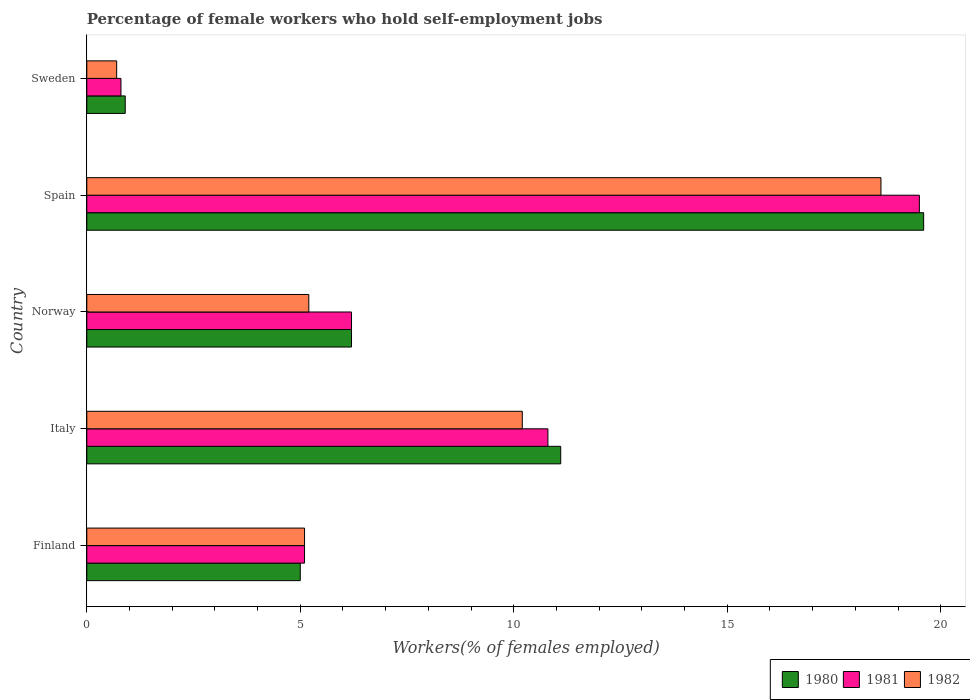How many groups of bars are there?
Offer a very short reply. 5. Are the number of bars per tick equal to the number of legend labels?
Make the answer very short. Yes. How many bars are there on the 3rd tick from the top?
Your answer should be very brief. 3. How many bars are there on the 5th tick from the bottom?
Give a very brief answer. 3. What is the percentage of self-employed female workers in 1981 in Sweden?
Give a very brief answer. 0.8. Across all countries, what is the maximum percentage of self-employed female workers in 1980?
Your response must be concise. 19.6. Across all countries, what is the minimum percentage of self-employed female workers in 1980?
Your response must be concise. 0.9. In which country was the percentage of self-employed female workers in 1981 maximum?
Make the answer very short. Spain. What is the total percentage of self-employed female workers in 1981 in the graph?
Ensure brevity in your answer.  42.4. What is the difference between the percentage of self-employed female workers in 1981 in Spain and that in Sweden?
Keep it short and to the point. 18.7. What is the difference between the percentage of self-employed female workers in 1980 in Spain and the percentage of self-employed female workers in 1982 in Finland?
Make the answer very short. 14.5. What is the average percentage of self-employed female workers in 1980 per country?
Ensure brevity in your answer.  8.56. What is the difference between the percentage of self-employed female workers in 1981 and percentage of self-employed female workers in 1980 in Norway?
Provide a short and direct response. 0. In how many countries, is the percentage of self-employed female workers in 1981 greater than 3 %?
Ensure brevity in your answer.  4. What is the ratio of the percentage of self-employed female workers in 1982 in Finland to that in Spain?
Ensure brevity in your answer.  0.27. Is the difference between the percentage of self-employed female workers in 1981 in Finland and Italy greater than the difference between the percentage of self-employed female workers in 1980 in Finland and Italy?
Offer a very short reply. Yes. What is the difference between the highest and the second highest percentage of self-employed female workers in 1982?
Ensure brevity in your answer.  8.4. What is the difference between the highest and the lowest percentage of self-employed female workers in 1980?
Your response must be concise. 18.7. In how many countries, is the percentage of self-employed female workers in 1980 greater than the average percentage of self-employed female workers in 1980 taken over all countries?
Make the answer very short. 2. What does the 3rd bar from the top in Spain represents?
Your response must be concise. 1980. How many bars are there?
Your answer should be very brief. 15. Are all the bars in the graph horizontal?
Offer a terse response. Yes. Does the graph contain grids?
Provide a succinct answer. No. How many legend labels are there?
Provide a short and direct response. 3. How are the legend labels stacked?
Keep it short and to the point. Horizontal. What is the title of the graph?
Offer a terse response. Percentage of female workers who hold self-employment jobs. Does "1982" appear as one of the legend labels in the graph?
Your response must be concise. Yes. What is the label or title of the X-axis?
Provide a short and direct response. Workers(% of females employed). What is the Workers(% of females employed) of 1981 in Finland?
Your answer should be compact. 5.1. What is the Workers(% of females employed) in 1982 in Finland?
Offer a very short reply. 5.1. What is the Workers(% of females employed) in 1980 in Italy?
Keep it short and to the point. 11.1. What is the Workers(% of females employed) in 1981 in Italy?
Ensure brevity in your answer.  10.8. What is the Workers(% of females employed) of 1982 in Italy?
Provide a succinct answer. 10.2. What is the Workers(% of females employed) of 1980 in Norway?
Your response must be concise. 6.2. What is the Workers(% of females employed) in 1981 in Norway?
Keep it short and to the point. 6.2. What is the Workers(% of females employed) of 1982 in Norway?
Keep it short and to the point. 5.2. What is the Workers(% of females employed) of 1980 in Spain?
Your response must be concise. 19.6. What is the Workers(% of females employed) of 1982 in Spain?
Your answer should be very brief. 18.6. What is the Workers(% of females employed) in 1980 in Sweden?
Make the answer very short. 0.9. What is the Workers(% of females employed) in 1981 in Sweden?
Your response must be concise. 0.8. What is the Workers(% of females employed) of 1982 in Sweden?
Provide a succinct answer. 0.7. Across all countries, what is the maximum Workers(% of females employed) in 1980?
Your answer should be very brief. 19.6. Across all countries, what is the maximum Workers(% of females employed) in 1982?
Your response must be concise. 18.6. Across all countries, what is the minimum Workers(% of females employed) in 1980?
Offer a terse response. 0.9. Across all countries, what is the minimum Workers(% of females employed) in 1981?
Your answer should be very brief. 0.8. Across all countries, what is the minimum Workers(% of females employed) in 1982?
Your response must be concise. 0.7. What is the total Workers(% of females employed) in 1980 in the graph?
Make the answer very short. 42.8. What is the total Workers(% of females employed) of 1981 in the graph?
Offer a very short reply. 42.4. What is the total Workers(% of females employed) of 1982 in the graph?
Your response must be concise. 39.8. What is the difference between the Workers(% of females employed) in 1980 in Finland and that in Italy?
Your answer should be compact. -6.1. What is the difference between the Workers(% of females employed) of 1981 in Finland and that in Italy?
Your answer should be very brief. -5.7. What is the difference between the Workers(% of females employed) of 1981 in Finland and that in Norway?
Your answer should be compact. -1.1. What is the difference between the Workers(% of females employed) of 1980 in Finland and that in Spain?
Keep it short and to the point. -14.6. What is the difference between the Workers(% of females employed) in 1981 in Finland and that in Spain?
Your response must be concise. -14.4. What is the difference between the Workers(% of females employed) in 1982 in Finland and that in Spain?
Your answer should be very brief. -13.5. What is the difference between the Workers(% of females employed) of 1981 in Italy and that in Norway?
Your answer should be compact. 4.6. What is the difference between the Workers(% of females employed) of 1982 in Italy and that in Norway?
Provide a succinct answer. 5. What is the difference between the Workers(% of females employed) in 1981 in Italy and that in Spain?
Keep it short and to the point. -8.7. What is the difference between the Workers(% of females employed) of 1982 in Italy and that in Spain?
Make the answer very short. -8.4. What is the difference between the Workers(% of females employed) of 1980 in Italy and that in Sweden?
Provide a succinct answer. 10.2. What is the difference between the Workers(% of females employed) of 1981 in Norway and that in Spain?
Make the answer very short. -13.3. What is the difference between the Workers(% of females employed) in 1980 in Norway and that in Sweden?
Give a very brief answer. 5.3. What is the difference between the Workers(% of females employed) of 1981 in Norway and that in Sweden?
Your answer should be compact. 5.4. What is the difference between the Workers(% of females employed) of 1980 in Spain and that in Sweden?
Provide a short and direct response. 18.7. What is the difference between the Workers(% of females employed) of 1980 in Finland and the Workers(% of females employed) of 1982 in Italy?
Ensure brevity in your answer.  -5.2. What is the difference between the Workers(% of females employed) of 1981 in Finland and the Workers(% of females employed) of 1982 in Italy?
Provide a short and direct response. -5.1. What is the difference between the Workers(% of females employed) in 1980 in Finland and the Workers(% of females employed) in 1981 in Spain?
Make the answer very short. -14.5. What is the difference between the Workers(% of females employed) in 1981 in Finland and the Workers(% of females employed) in 1982 in Spain?
Provide a short and direct response. -13.5. What is the difference between the Workers(% of females employed) in 1981 in Finland and the Workers(% of females employed) in 1982 in Sweden?
Your response must be concise. 4.4. What is the difference between the Workers(% of females employed) of 1980 in Italy and the Workers(% of females employed) of 1982 in Norway?
Offer a terse response. 5.9. What is the difference between the Workers(% of females employed) of 1980 in Italy and the Workers(% of females employed) of 1981 in Spain?
Offer a very short reply. -8.4. What is the difference between the Workers(% of females employed) in 1980 in Italy and the Workers(% of females employed) in 1982 in Spain?
Your response must be concise. -7.5. What is the difference between the Workers(% of females employed) of 1980 in Italy and the Workers(% of females employed) of 1982 in Sweden?
Provide a short and direct response. 10.4. What is the difference between the Workers(% of females employed) of 1981 in Italy and the Workers(% of females employed) of 1982 in Sweden?
Your answer should be compact. 10.1. What is the difference between the Workers(% of females employed) in 1980 in Norway and the Workers(% of females employed) in 1981 in Spain?
Ensure brevity in your answer.  -13.3. What is the difference between the Workers(% of females employed) in 1981 in Norway and the Workers(% of females employed) in 1982 in Spain?
Make the answer very short. -12.4. What is the difference between the Workers(% of females employed) in 1980 in Spain and the Workers(% of females employed) in 1982 in Sweden?
Give a very brief answer. 18.9. What is the difference between the Workers(% of females employed) in 1981 in Spain and the Workers(% of females employed) in 1982 in Sweden?
Offer a terse response. 18.8. What is the average Workers(% of females employed) in 1980 per country?
Provide a succinct answer. 8.56. What is the average Workers(% of females employed) in 1981 per country?
Your answer should be compact. 8.48. What is the average Workers(% of females employed) in 1982 per country?
Your answer should be very brief. 7.96. What is the difference between the Workers(% of females employed) in 1980 and Workers(% of females employed) in 1981 in Italy?
Give a very brief answer. 0.3. What is the difference between the Workers(% of females employed) in 1980 and Workers(% of females employed) in 1982 in Italy?
Your answer should be very brief. 0.9. What is the difference between the Workers(% of females employed) in 1980 and Workers(% of females employed) in 1981 in Norway?
Your answer should be compact. 0. What is the difference between the Workers(% of females employed) of 1980 and Workers(% of females employed) of 1982 in Norway?
Ensure brevity in your answer.  1. What is the difference between the Workers(% of females employed) in 1980 and Workers(% of females employed) in 1981 in Spain?
Your answer should be very brief. 0.1. What is the difference between the Workers(% of females employed) of 1980 and Workers(% of females employed) of 1982 in Spain?
Make the answer very short. 1. What is the difference between the Workers(% of females employed) in 1981 and Workers(% of females employed) in 1982 in Spain?
Provide a succinct answer. 0.9. What is the difference between the Workers(% of females employed) of 1980 and Workers(% of females employed) of 1981 in Sweden?
Give a very brief answer. 0.1. What is the difference between the Workers(% of females employed) of 1980 and Workers(% of females employed) of 1982 in Sweden?
Offer a terse response. 0.2. What is the difference between the Workers(% of females employed) of 1981 and Workers(% of females employed) of 1982 in Sweden?
Provide a short and direct response. 0.1. What is the ratio of the Workers(% of females employed) in 1980 in Finland to that in Italy?
Offer a very short reply. 0.45. What is the ratio of the Workers(% of females employed) of 1981 in Finland to that in Italy?
Offer a very short reply. 0.47. What is the ratio of the Workers(% of females employed) in 1980 in Finland to that in Norway?
Give a very brief answer. 0.81. What is the ratio of the Workers(% of females employed) in 1981 in Finland to that in Norway?
Your answer should be very brief. 0.82. What is the ratio of the Workers(% of females employed) of 1982 in Finland to that in Norway?
Provide a short and direct response. 0.98. What is the ratio of the Workers(% of females employed) in 1980 in Finland to that in Spain?
Provide a succinct answer. 0.26. What is the ratio of the Workers(% of females employed) in 1981 in Finland to that in Spain?
Your answer should be compact. 0.26. What is the ratio of the Workers(% of females employed) in 1982 in Finland to that in Spain?
Offer a terse response. 0.27. What is the ratio of the Workers(% of females employed) of 1980 in Finland to that in Sweden?
Your answer should be compact. 5.56. What is the ratio of the Workers(% of females employed) in 1981 in Finland to that in Sweden?
Your response must be concise. 6.38. What is the ratio of the Workers(% of females employed) in 1982 in Finland to that in Sweden?
Your response must be concise. 7.29. What is the ratio of the Workers(% of females employed) in 1980 in Italy to that in Norway?
Your answer should be compact. 1.79. What is the ratio of the Workers(% of females employed) of 1981 in Italy to that in Norway?
Provide a short and direct response. 1.74. What is the ratio of the Workers(% of females employed) in 1982 in Italy to that in Norway?
Ensure brevity in your answer.  1.96. What is the ratio of the Workers(% of females employed) in 1980 in Italy to that in Spain?
Your response must be concise. 0.57. What is the ratio of the Workers(% of females employed) of 1981 in Italy to that in Spain?
Offer a terse response. 0.55. What is the ratio of the Workers(% of females employed) in 1982 in Italy to that in Spain?
Keep it short and to the point. 0.55. What is the ratio of the Workers(% of females employed) in 1980 in Italy to that in Sweden?
Make the answer very short. 12.33. What is the ratio of the Workers(% of females employed) of 1981 in Italy to that in Sweden?
Your answer should be very brief. 13.5. What is the ratio of the Workers(% of females employed) of 1982 in Italy to that in Sweden?
Give a very brief answer. 14.57. What is the ratio of the Workers(% of females employed) of 1980 in Norway to that in Spain?
Offer a very short reply. 0.32. What is the ratio of the Workers(% of females employed) of 1981 in Norway to that in Spain?
Your answer should be very brief. 0.32. What is the ratio of the Workers(% of females employed) of 1982 in Norway to that in Spain?
Your response must be concise. 0.28. What is the ratio of the Workers(% of females employed) in 1980 in Norway to that in Sweden?
Keep it short and to the point. 6.89. What is the ratio of the Workers(% of females employed) of 1981 in Norway to that in Sweden?
Make the answer very short. 7.75. What is the ratio of the Workers(% of females employed) of 1982 in Norway to that in Sweden?
Offer a very short reply. 7.43. What is the ratio of the Workers(% of females employed) of 1980 in Spain to that in Sweden?
Offer a very short reply. 21.78. What is the ratio of the Workers(% of females employed) in 1981 in Spain to that in Sweden?
Provide a short and direct response. 24.38. What is the ratio of the Workers(% of females employed) of 1982 in Spain to that in Sweden?
Offer a very short reply. 26.57. What is the difference between the highest and the second highest Workers(% of females employed) of 1981?
Ensure brevity in your answer.  8.7. What is the difference between the highest and the lowest Workers(% of females employed) in 1981?
Ensure brevity in your answer.  18.7. 